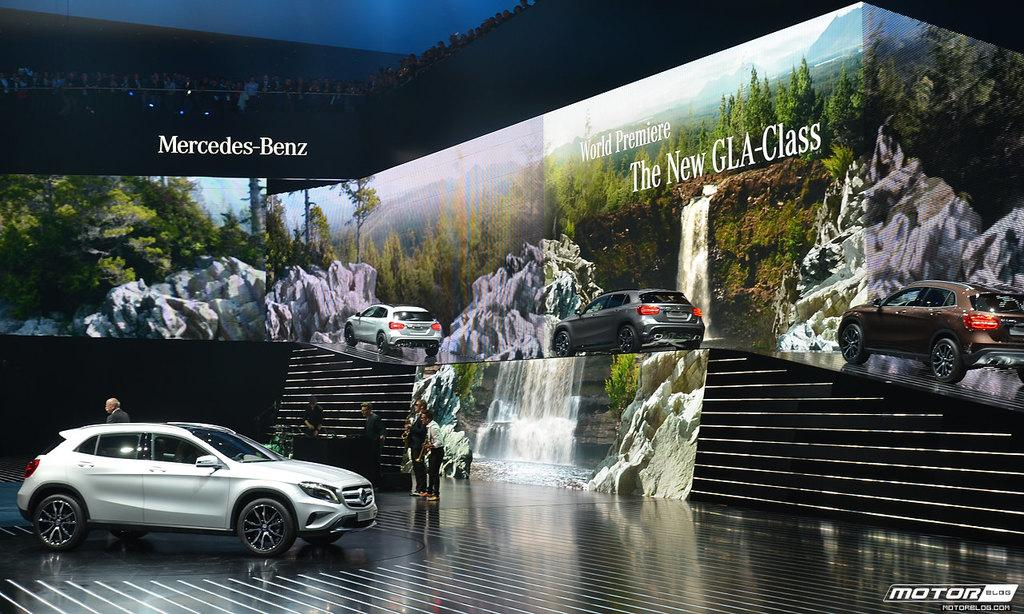What is the main subject of the image? There is a car in the image. Can you describe the people in the image? There are people in the image. What is on the floor in the image? There are objects on the floor in the image. What can be seen in the background of the image? There are vehicles on a platform, scenery, people, a wall, and objects in the background of the image. What shape is the smile on the car's bumper in the image? There is no smile on the car's bumper in the image; it is a car, not a person or an object with a smile. 